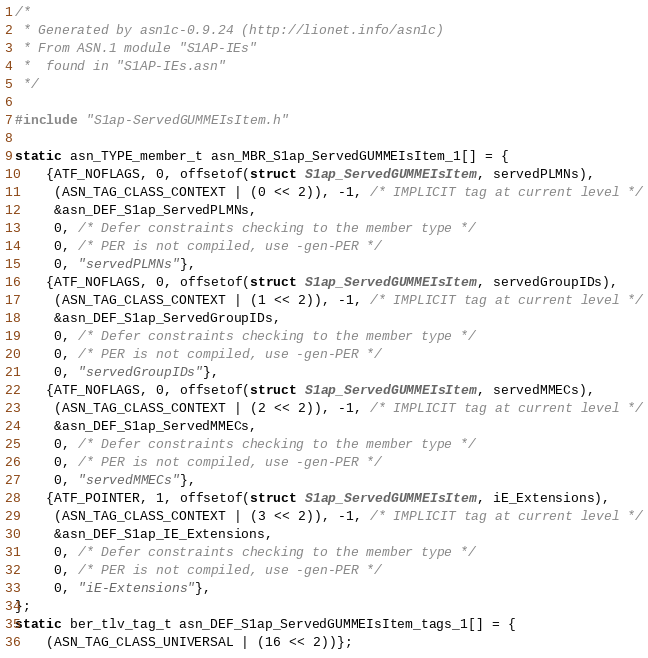<code> <loc_0><loc_0><loc_500><loc_500><_C_>/*
 * Generated by asn1c-0.9.24 (http://lionet.info/asn1c)
 * From ASN.1 module "S1AP-IEs"
 * 	found in "S1AP-IEs.asn"
 */

#include "S1ap-ServedGUMMEIsItem.h"

static asn_TYPE_member_t asn_MBR_S1ap_ServedGUMMEIsItem_1[] = {
    {ATF_NOFLAGS, 0, offsetof(struct S1ap_ServedGUMMEIsItem, servedPLMNs),
     (ASN_TAG_CLASS_CONTEXT | (0 << 2)), -1, /* IMPLICIT tag at current level */
     &asn_DEF_S1ap_ServedPLMNs,
     0, /* Defer constraints checking to the member type */
     0, /* PER is not compiled, use -gen-PER */
     0, "servedPLMNs"},
    {ATF_NOFLAGS, 0, offsetof(struct S1ap_ServedGUMMEIsItem, servedGroupIDs),
     (ASN_TAG_CLASS_CONTEXT | (1 << 2)), -1, /* IMPLICIT tag at current level */
     &asn_DEF_S1ap_ServedGroupIDs,
     0, /* Defer constraints checking to the member type */
     0, /* PER is not compiled, use -gen-PER */
     0, "servedGroupIDs"},
    {ATF_NOFLAGS, 0, offsetof(struct S1ap_ServedGUMMEIsItem, servedMMECs),
     (ASN_TAG_CLASS_CONTEXT | (2 << 2)), -1, /* IMPLICIT tag at current level */
     &asn_DEF_S1ap_ServedMMECs,
     0, /* Defer constraints checking to the member type */
     0, /* PER is not compiled, use -gen-PER */
     0, "servedMMECs"},
    {ATF_POINTER, 1, offsetof(struct S1ap_ServedGUMMEIsItem, iE_Extensions),
     (ASN_TAG_CLASS_CONTEXT | (3 << 2)), -1, /* IMPLICIT tag at current level */
     &asn_DEF_S1ap_IE_Extensions,
     0, /* Defer constraints checking to the member type */
     0, /* PER is not compiled, use -gen-PER */
     0, "iE-Extensions"},
};
static ber_tlv_tag_t asn_DEF_S1ap_ServedGUMMEIsItem_tags_1[] = {
    (ASN_TAG_CLASS_UNIVERSAL | (16 << 2))};</code> 